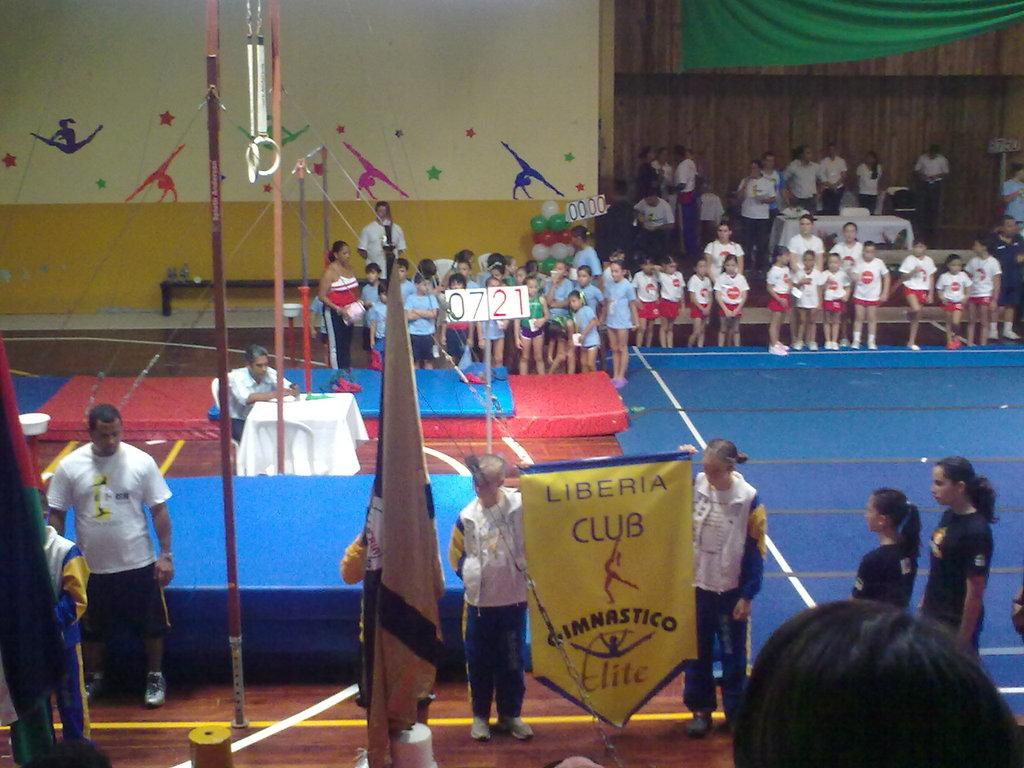How many kids are visible in the image? There are kids in the image, but the exact number is not specified. What are two of the kids doing in the image? Two kids are holding a poster in the image. Can you describe the other people in the image? There are other people in the image, but their actions or roles are not specified. What type of furniture is present in the image? There are tables in the image. What can be seen on the walls in the image? There are paintings on the wall in the image. What type of tank is visible in the image? There is no tank present in the image. What team are the kids representing in the image? The image does not indicate that the kids are part of a team or representing any particular group. 